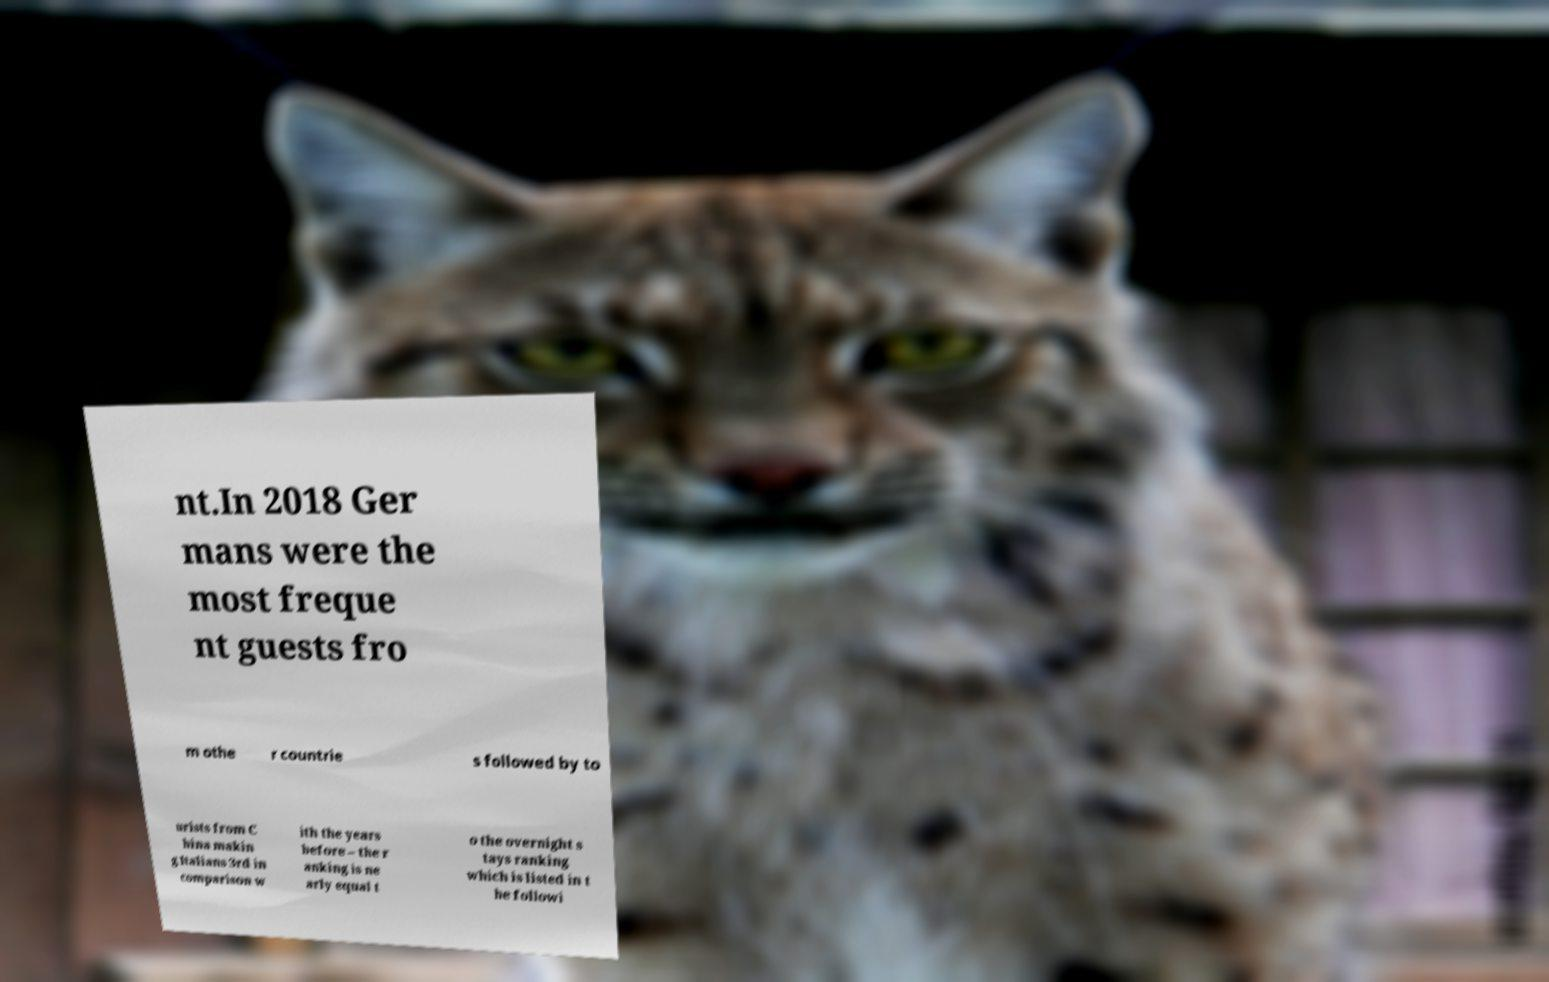For documentation purposes, I need the text within this image transcribed. Could you provide that? nt.In 2018 Ger mans were the most freque nt guests fro m othe r countrie s followed by to urists from C hina makin g Italians 3rd in comparison w ith the years before – the r anking is ne arly equal t o the overnight s tays ranking which is listed in t he followi 